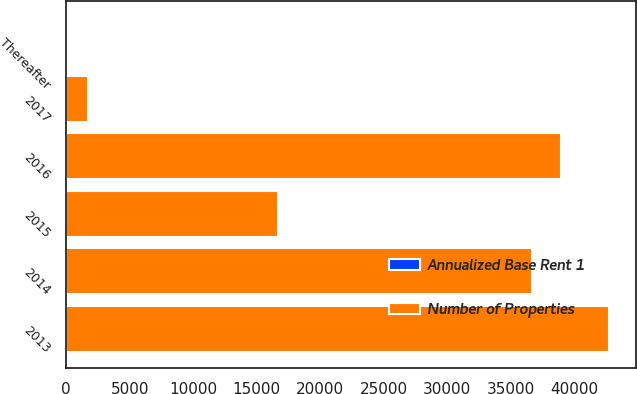Convert chart to OTSL. <chart><loc_0><loc_0><loc_500><loc_500><stacked_bar_chart><ecel><fcel>2013<fcel>2014<fcel>2015<fcel>2016<fcel>2017<fcel>Thereafter<nl><fcel>Number of Properties<fcel>42700<fcel>36666<fcel>16702<fcel>38933<fcel>1685<fcel>58<nl><fcel>Annualized Base Rent 1<fcel>23<fcel>15<fcel>15<fcel>18<fcel>2<fcel>58<nl></chart> 